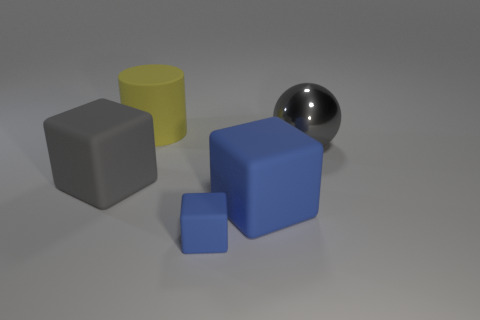Is there any other thing that has the same material as the ball?
Keep it short and to the point. No. There is a large gray matte thing; is its shape the same as the large matte object that is to the right of the large matte cylinder?
Offer a very short reply. Yes. There is a metallic thing; are there any big matte blocks left of it?
Make the answer very short. Yes. What number of spheres are either yellow things or big gray objects?
Ensure brevity in your answer.  1. Does the large blue thing have the same shape as the tiny blue object?
Provide a succinct answer. Yes. What size is the gray thing right of the large gray rubber object?
Your response must be concise. Large. Is there a shiny ball of the same color as the small matte object?
Your response must be concise. No. Do the gray object that is left of the yellow object and the large yellow matte cylinder have the same size?
Provide a succinct answer. Yes. The tiny matte block has what color?
Offer a terse response. Blue. The large matte block that is left of the object behind the large gray sphere is what color?
Give a very brief answer. Gray. 